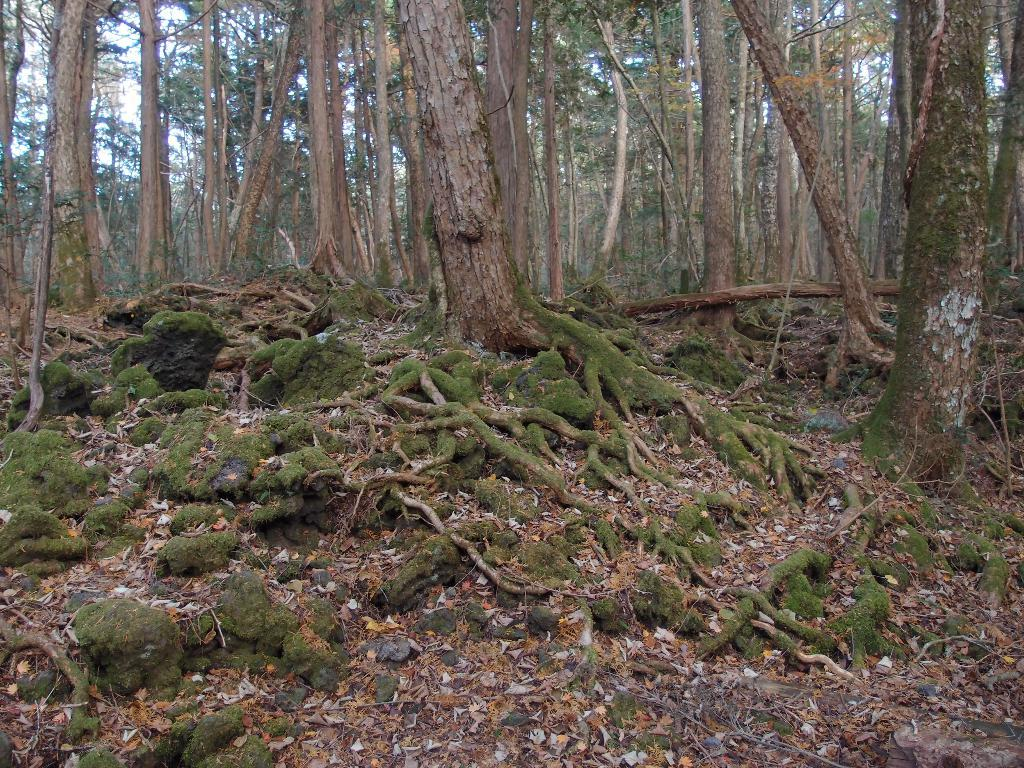What type of environment is depicted in the image? The image is taken in a forest. What can be seen in the foreground of the image? There are dry leaves, grass, and roots in the foreground of the image. What is the main feature of the image? There are trees in the center of the image. What type of cracker is being used to destroy the trees in the image? There is no cracker or destruction present in the image; it depicts a forest with trees. Can you hear the voice of the person who planted the trees in the image? There is no voice or person present in the image; it is a still photograph of a forest. 